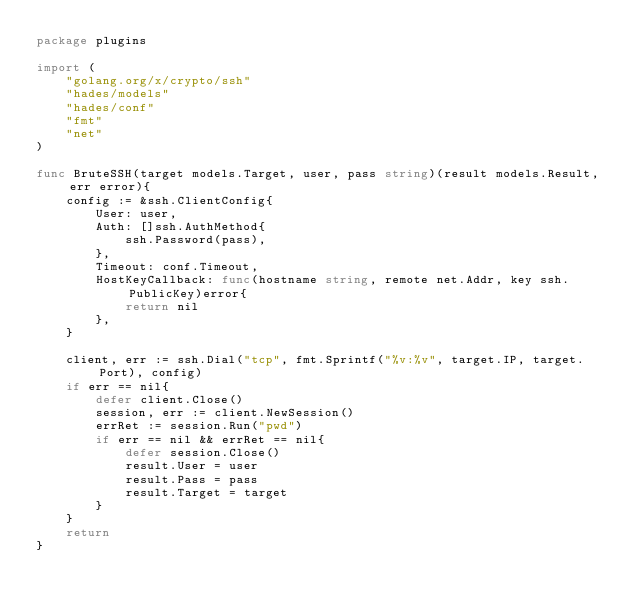<code> <loc_0><loc_0><loc_500><loc_500><_Go_>package plugins

import (
    "golang.org/x/crypto/ssh"
    "hades/models"
    "hades/conf"
    "fmt"
    "net"
)

func BruteSSH(target models.Target, user, pass string)(result models.Result, err error){
    config := &ssh.ClientConfig{
        User: user,
        Auth: []ssh.AuthMethod{
            ssh.Password(pass),
        },
        Timeout: conf.Timeout,
        HostKeyCallback: func(hostname string, remote net.Addr, key ssh.PublicKey)error{
            return nil
        },
    }

    client, err := ssh.Dial("tcp", fmt.Sprintf("%v:%v", target.IP, target.Port), config)
    if err == nil{
        defer client.Close()
        session, err := client.NewSession()
        errRet := session.Run("pwd")
        if err == nil && errRet == nil{
            defer session.Close()
            result.User = user
            result.Pass = pass
            result.Target = target
        }
    }
    return
}
</code> 